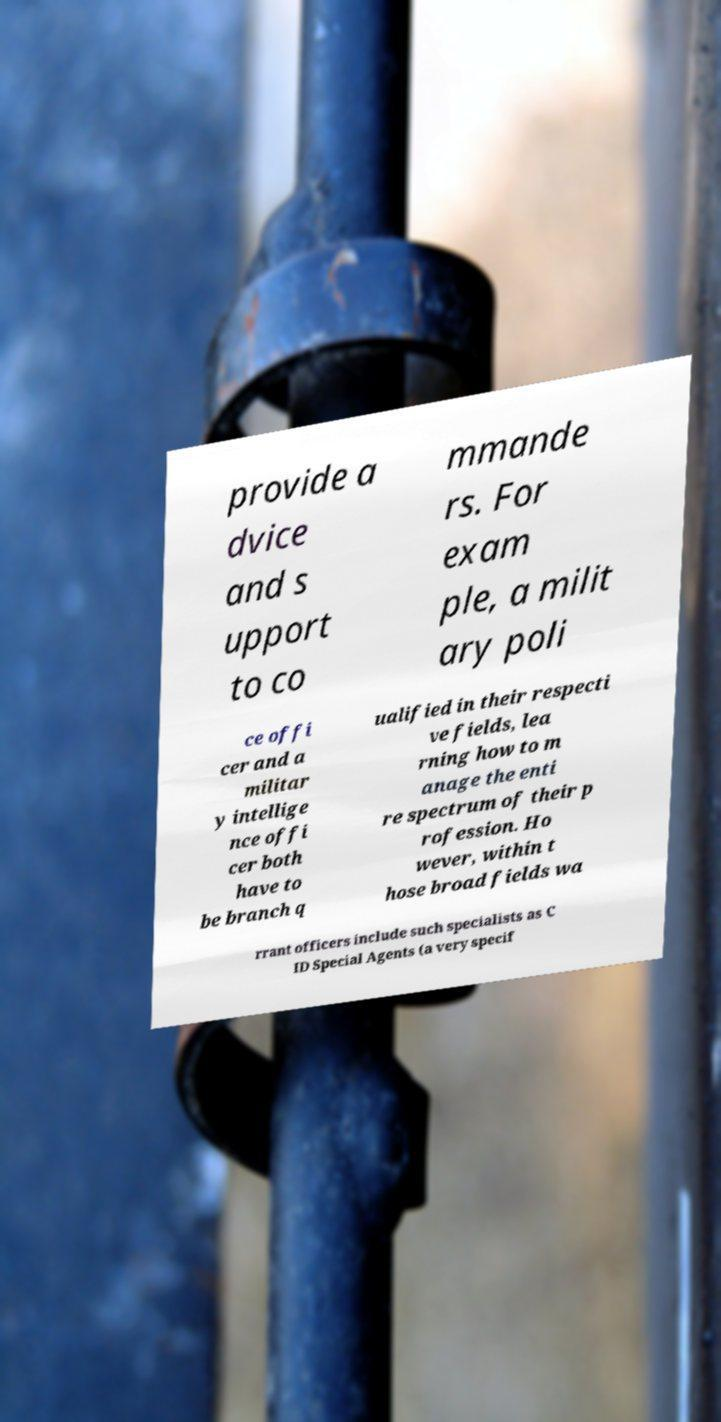Please read and relay the text visible in this image. What does it say? provide a dvice and s upport to co mmande rs. For exam ple, a milit ary poli ce offi cer and a militar y intellige nce offi cer both have to be branch q ualified in their respecti ve fields, lea rning how to m anage the enti re spectrum of their p rofession. Ho wever, within t hose broad fields wa rrant officers include such specialists as C ID Special Agents (a very specif 